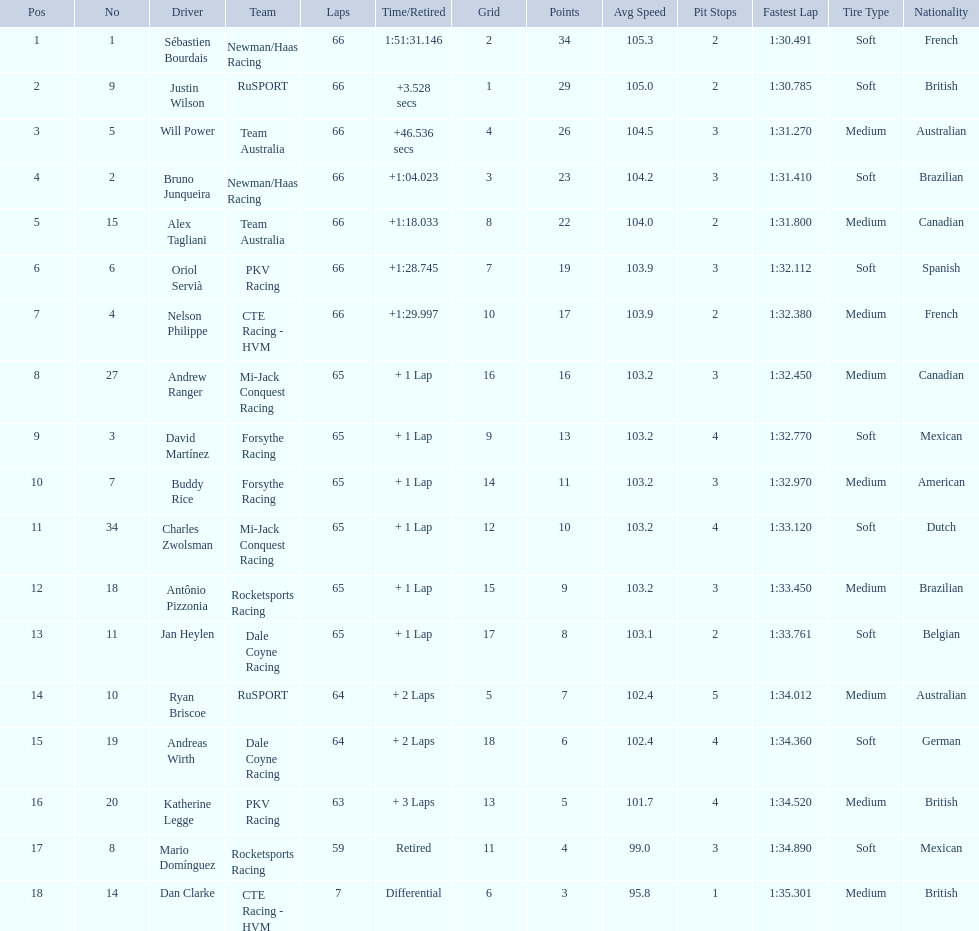Which drivers scored at least 10 points? Sébastien Bourdais, Justin Wilson, Will Power, Bruno Junqueira, Alex Tagliani, Oriol Servià, Nelson Philippe, Andrew Ranger, David Martínez, Buddy Rice, Charles Zwolsman. Of those drivers, which ones scored at least 20 points? Sébastien Bourdais, Justin Wilson, Will Power, Bruno Junqueira, Alex Tagliani. Of those 5, which driver scored the most points? Sébastien Bourdais. 